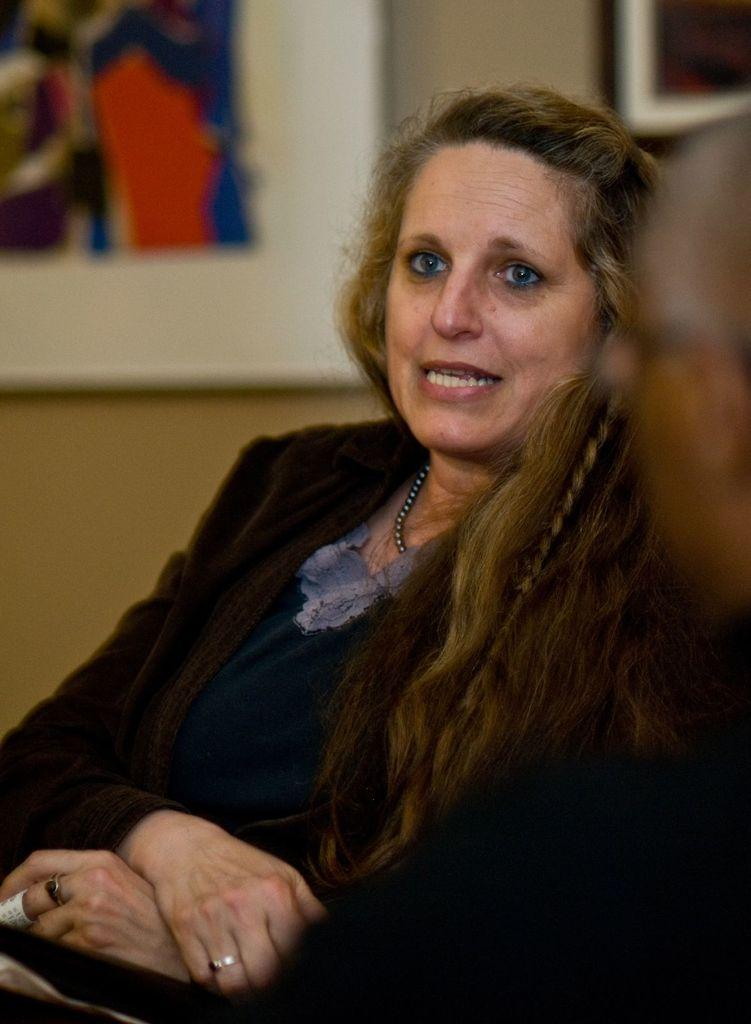What is the lady in the image doing? The lady is sitting in the image. Who is with the lady in the image? A: There is a person beside the lady in the image. What can be seen on the wall in the background of the image? There are frames hanging on the wall in the background of the image. What type of horn can be seen on the lady's head in the image? There is no horn present on the lady's head in the image. How many lizards are sitting on the person's shoulder in the image? There are no lizards present in the image. 